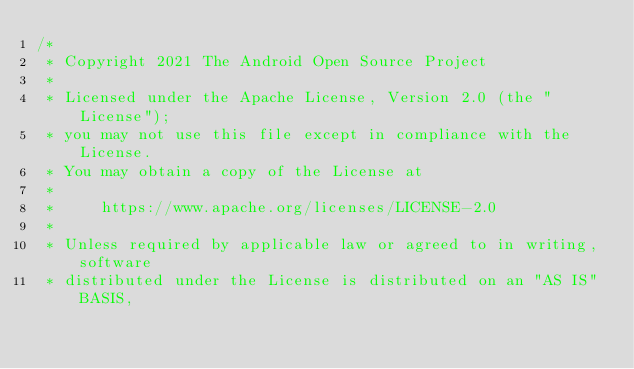Convert code to text. <code><loc_0><loc_0><loc_500><loc_500><_Kotlin_>/*
 * Copyright 2021 The Android Open Source Project
 *
 * Licensed under the Apache License, Version 2.0 (the "License");
 * you may not use this file except in compliance with the License.
 * You may obtain a copy of the License at
 *
 *     https://www.apache.org/licenses/LICENSE-2.0
 *
 * Unless required by applicable law or agreed to in writing, software
 * distributed under the License is distributed on an "AS IS" BASIS,</code> 